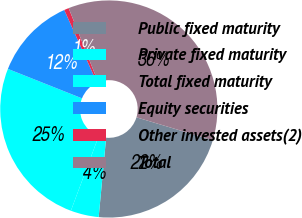<chart> <loc_0><loc_0><loc_500><loc_500><pie_chart><fcel>Public fixed maturity<fcel>Private fixed maturity<fcel>Total fixed maturity<fcel>Equity securities<fcel>Other invested assets(2)<fcel>Total<nl><fcel>21.84%<fcel>4.19%<fcel>25.34%<fcel>12.25%<fcel>0.7%<fcel>35.68%<nl></chart> 